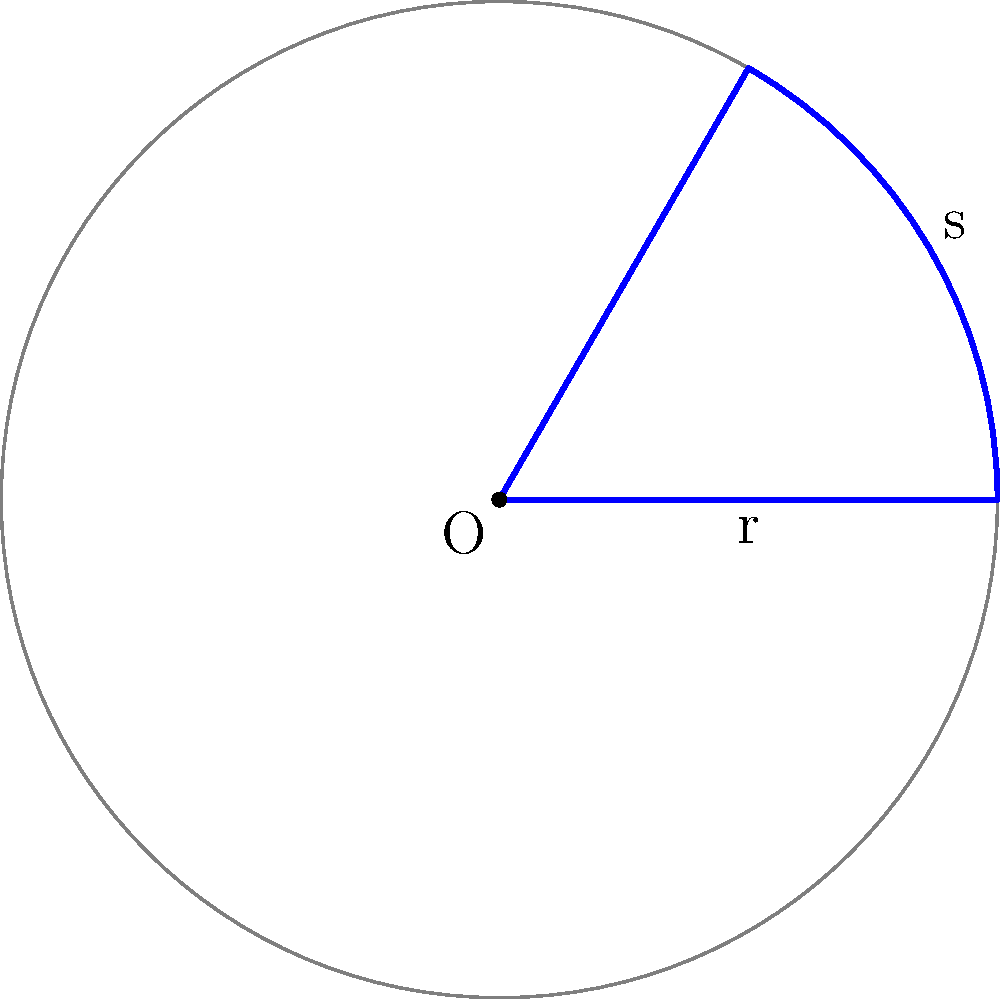While preparing for your child's birthday party, you're cutting a large circular pizza into slices. The pizza has a radius of 12 inches, and you want each slice to have an arc length of 8 inches along the crust. What is the central angle (in degrees) of each pizza slice? Let's approach this step-by-step:

1) We know that the relationship between arc length ($s$), radius ($r$), and central angle ($\theta$) in radians is:

   $$s = r\theta$$

2) We're given:
   - Radius ($r$) = 12 inches
   - Arc length ($s$) = 8 inches

3) Let's substitute these into our equation:

   $$8 = 12\theta$$

4) Now, let's solve for $\theta$:

   $$\theta = \frac{8}{12} = \frac{2}{3}$$

5) This gives us the angle in radians. To convert to degrees, we multiply by $\frac{180}{\pi}$:

   $$\theta_{degrees} = \frac{2}{3} \cdot \frac{180}{\pi} \approx 38.2$$

6) Rounding to the nearest degree:

   $$\theta_{degrees} \approx 38°$$

Therefore, each pizza slice should have a central angle of approximately 38 degrees.
Answer: 38° 